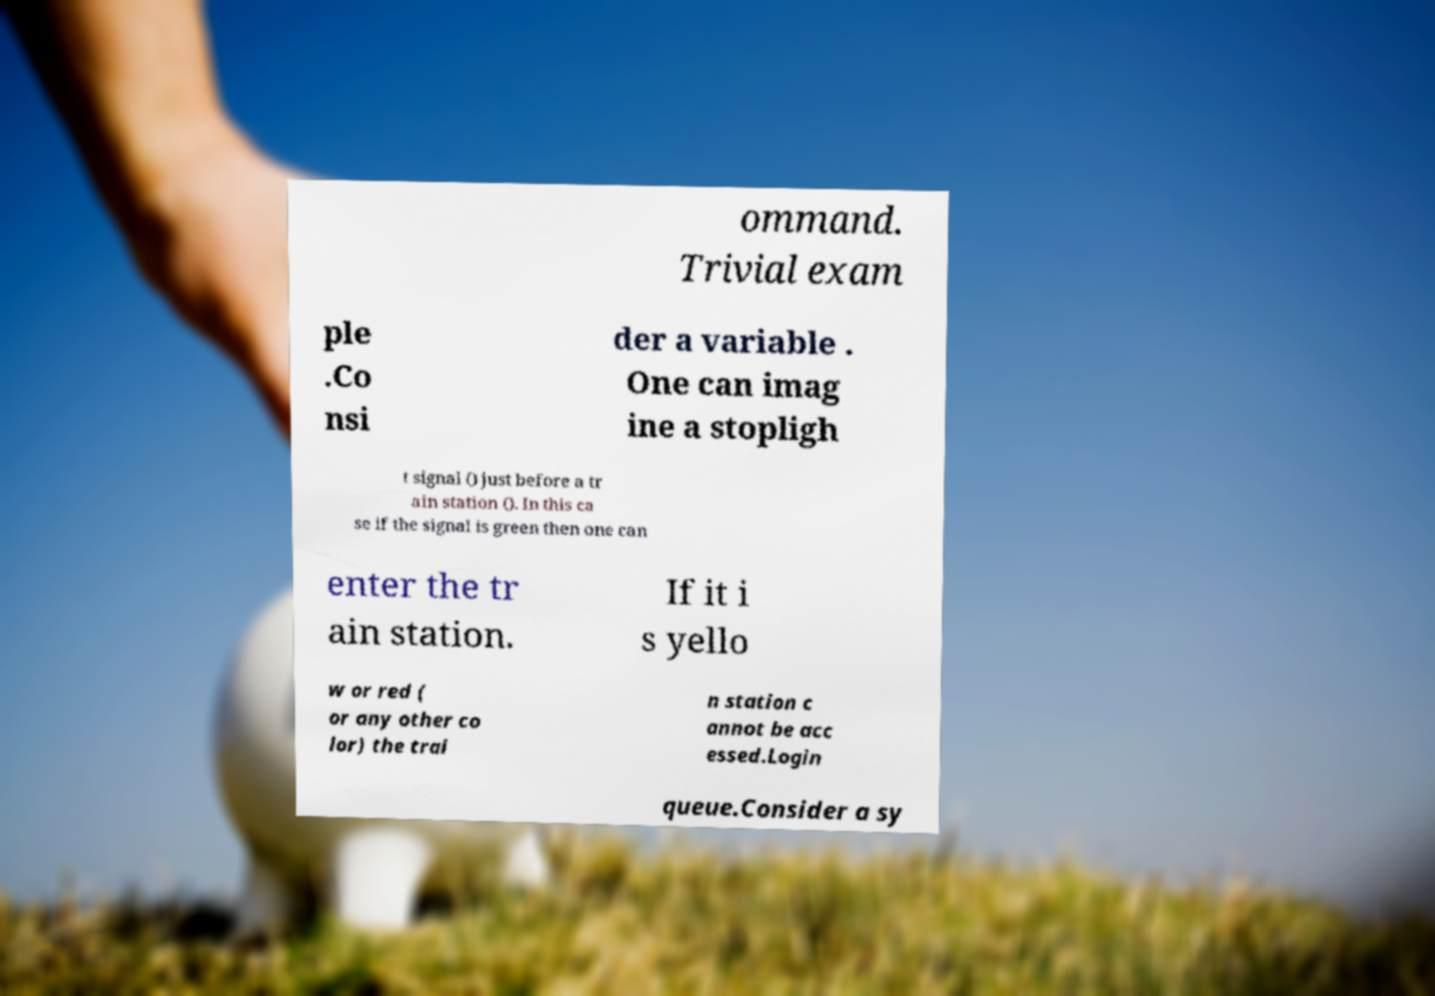For documentation purposes, I need the text within this image transcribed. Could you provide that? ommand. Trivial exam ple .Co nsi der a variable . One can imag ine a stopligh t signal () just before a tr ain station (). In this ca se if the signal is green then one can enter the tr ain station. If it i s yello w or red ( or any other co lor) the trai n station c annot be acc essed.Login queue.Consider a sy 